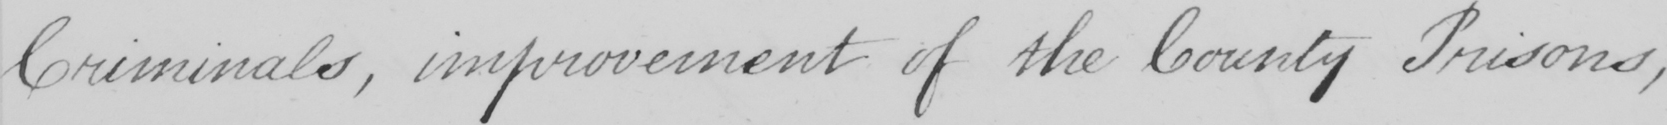What is written in this line of handwriting? Criminals , improvement of the County Prisons , 